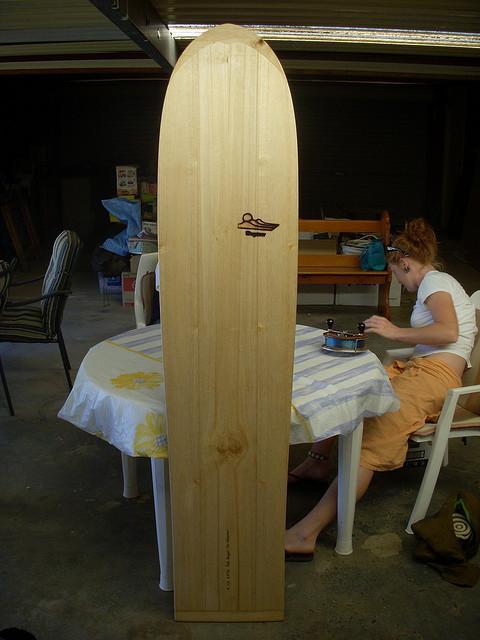How many chairs are there?
Give a very brief answer. 2. 